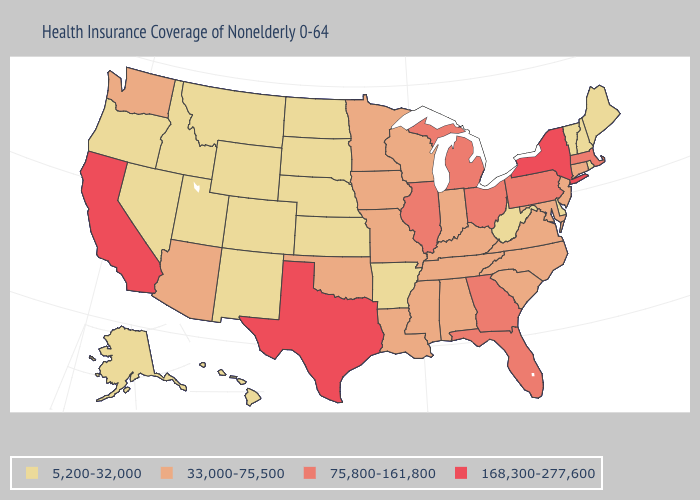Among the states that border New Jersey , does Delaware have the lowest value?
Answer briefly. Yes. Among the states that border New York , does Connecticut have the highest value?
Be succinct. No. What is the value of Oklahoma?
Write a very short answer. 33,000-75,500. Does the first symbol in the legend represent the smallest category?
Keep it brief. Yes. What is the value of Texas?
Be succinct. 168,300-277,600. Name the states that have a value in the range 33,000-75,500?
Concise answer only. Alabama, Arizona, Connecticut, Indiana, Iowa, Kentucky, Louisiana, Maryland, Minnesota, Mississippi, Missouri, New Jersey, North Carolina, Oklahoma, South Carolina, Tennessee, Virginia, Washington, Wisconsin. Does South Carolina have the lowest value in the USA?
Write a very short answer. No. Among the states that border Kansas , which have the highest value?
Concise answer only. Missouri, Oklahoma. Name the states that have a value in the range 5,200-32,000?
Be succinct. Alaska, Arkansas, Colorado, Delaware, Hawaii, Idaho, Kansas, Maine, Montana, Nebraska, Nevada, New Hampshire, New Mexico, North Dakota, Oregon, Rhode Island, South Dakota, Utah, Vermont, West Virginia, Wyoming. What is the value of New Hampshire?
Quick response, please. 5,200-32,000. What is the value of Louisiana?
Give a very brief answer. 33,000-75,500. Name the states that have a value in the range 33,000-75,500?
Be succinct. Alabama, Arizona, Connecticut, Indiana, Iowa, Kentucky, Louisiana, Maryland, Minnesota, Mississippi, Missouri, New Jersey, North Carolina, Oklahoma, South Carolina, Tennessee, Virginia, Washington, Wisconsin. Does Alaska have a higher value than Maine?
Keep it brief. No. Name the states that have a value in the range 75,800-161,800?
Short answer required. Florida, Georgia, Illinois, Massachusetts, Michigan, Ohio, Pennsylvania. Name the states that have a value in the range 75,800-161,800?
Be succinct. Florida, Georgia, Illinois, Massachusetts, Michigan, Ohio, Pennsylvania. 